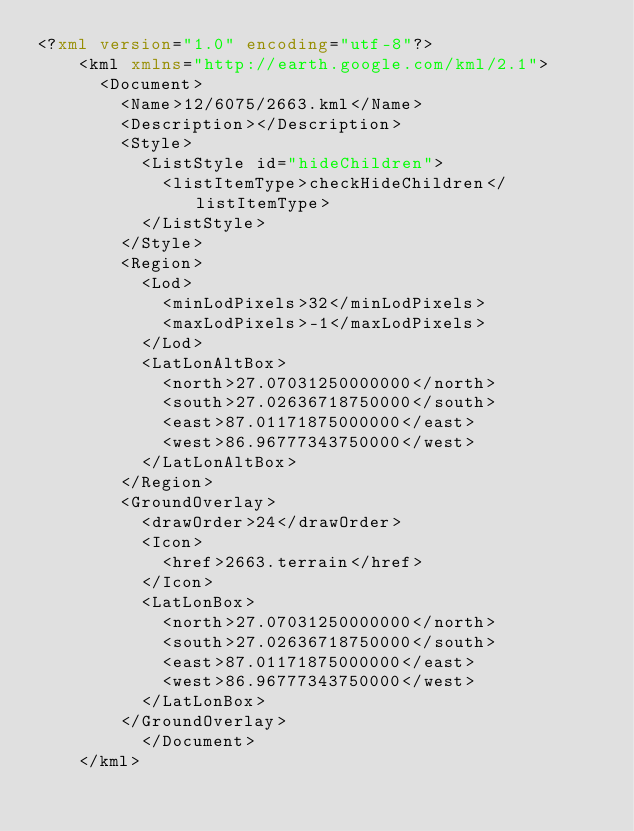<code> <loc_0><loc_0><loc_500><loc_500><_XML_><?xml version="1.0" encoding="utf-8"?>
	<kml xmlns="http://earth.google.com/kml/2.1">
	  <Document>
	    <Name>12/6075/2663.kml</Name>
	    <Description></Description>
	    <Style>
	      <ListStyle id="hideChildren">
	        <listItemType>checkHideChildren</listItemType>
	      </ListStyle>
	    </Style>
	    <Region>
	      <Lod>
	        <minLodPixels>32</minLodPixels>
	        <maxLodPixels>-1</maxLodPixels>
	      </Lod>
	      <LatLonAltBox>
	        <north>27.07031250000000</north>
	        <south>27.02636718750000</south>
	        <east>87.01171875000000</east>
	        <west>86.96777343750000</west>
	      </LatLonAltBox>
	    </Region>
	    <GroundOverlay>
	      <drawOrder>24</drawOrder>
	      <Icon>
	        <href>2663.terrain</href>
	      </Icon>
	      <LatLonBox>
	        <north>27.07031250000000</north>
	        <south>27.02636718750000</south>
	        <east>87.01171875000000</east>
	        <west>86.96777343750000</west>
	      </LatLonBox>
	    </GroundOverlay>
		  </Document>
	</kml>
	</code> 